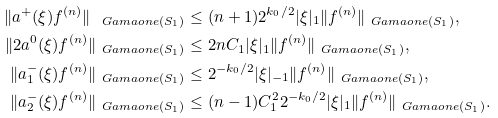<formula> <loc_0><loc_0><loc_500><loc_500>\| a ^ { + } ( \xi ) f ^ { ( n ) } \| _ { \ G a m a o n e ( S _ { 1 } ) } & \leq ( n + 1 ) 2 ^ { k _ { 0 } / 2 } | \xi | _ { 1 } \| f ^ { ( n ) } \| _ { \ G a m a o n e ( S _ { 1 } ) } , \\ \| 2 a ^ { 0 } ( \xi ) f ^ { ( n ) } \| _ { \ G a m a o n e ( S _ { 1 } ) } & \leq 2 n C _ { 1 } | \xi | _ { 1 } \| f ^ { ( n ) } \| _ { \ G a m a o n e ( S _ { 1 } ) } , \\ \| a _ { 1 } ^ { - } ( \xi ) f ^ { ( n ) } \| _ { \ G a m a o n e ( S _ { 1 } ) } & \leq 2 ^ { - k _ { 0 } / 2 } | \xi | _ { - 1 } \| f ^ { ( n ) } \| _ { \ G a m a o n e ( S _ { 1 } ) } , \\ \| a _ { 2 } ^ { - } ( \xi ) f ^ { ( n ) } \| _ { \ G a m a o n e ( S _ { 1 } ) } & \leq ( n - 1 ) C _ { 1 } ^ { 2 } 2 ^ { - k _ { 0 } / 2 } | \xi | _ { 1 } \| f ^ { ( n ) } \| _ { \ G a m a o n e ( S _ { 1 } ) } .</formula> 